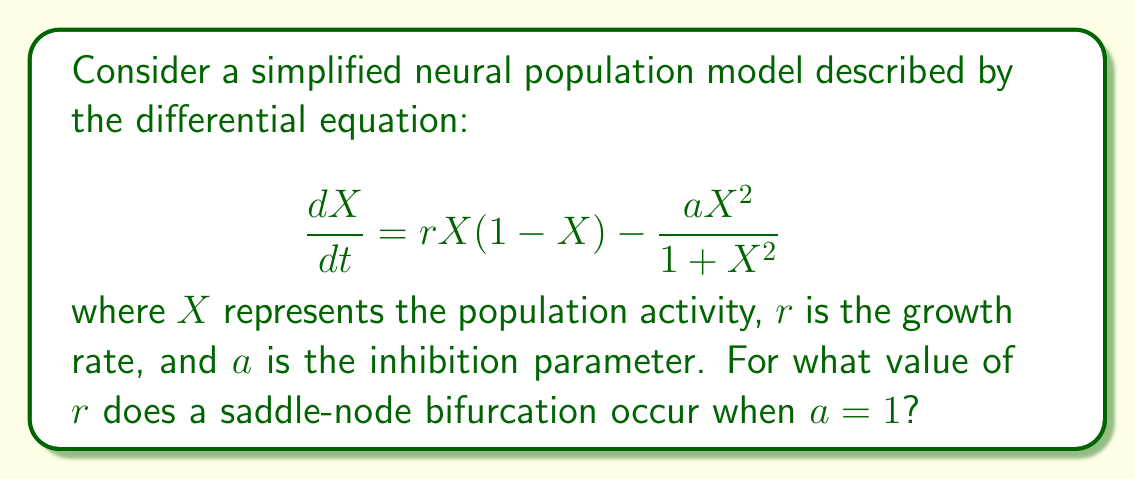Teach me how to tackle this problem. To find the saddle-node bifurcation point, we need to follow these steps:

1) First, find the equilibrium points by setting $\frac{dX}{dt} = 0$:

   $$rX(1-X) - \frac{X^2}{1+X^2} = 0$$

2) Rearrange the equation:

   $$rX - rX^2 - \frac{X^2}{1+X^2} = 0$$

3) Multiply both sides by $(1+X^2)$:

   $$rX(1+X^2) - rX^2(1+X^2) - X^2 = 0$$

4) Expand:

   $$rX + rX^3 - rX^2 - rX^4 - X^2 = 0$$

5) Collect terms:

   $$rX^3 - rX^4 + rX - (r+1)X^2 = 0$$

6) Factor out $X$:

   $$X(rX^2 - rX^3 + r - (r+1)X) = 0$$

7) One solution is $X=0$. For the other solutions:

   $$rX^2 - rX^3 + r - (r+1)X = 0$$

8) At the saddle-node bifurcation, this equation should have a double root. This occurs when the derivative of this equation with respect to $X$ is also zero:

   $$2rX - 3rX^2 - (r+1) = 0$$

9) For a double root, both equations (from steps 7 and 8) should be satisfied simultaneously. Divide the equation from step 7 by $X$:

   $$rX - rX^2 + \frac{r}{X} - (r+1) = 0$$

10) Subtracting the equation in step 8 from this:

    $$-rX + \frac{r}{X} + 1 = 0$$

11) Multiply by $X$:

    $$-rX^2 + r + X = 0$$

12) Solve for $X$:

    $$X = \frac{1 \pm \sqrt{1+4r^2}}{2r}$$

13) At the saddle-node bifurcation, these roots coincide, which occurs when the discriminant is zero:

    $$1+4r^2 = 0$$

14) Solve for $r$:

    $$r = \frac{1}{2}$$

Therefore, the saddle-node bifurcation occurs when $r = \frac{1}{2}$.
Answer: $\frac{1}{2}$ 